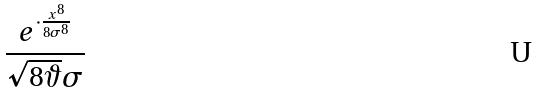Convert formula to latex. <formula><loc_0><loc_0><loc_500><loc_500>\frac { e ^ { \cdot \frac { x ^ { 8 } } { 8 \sigma ^ { 8 } } } } { \sqrt { 8 \vartheta } \sigma }</formula> 